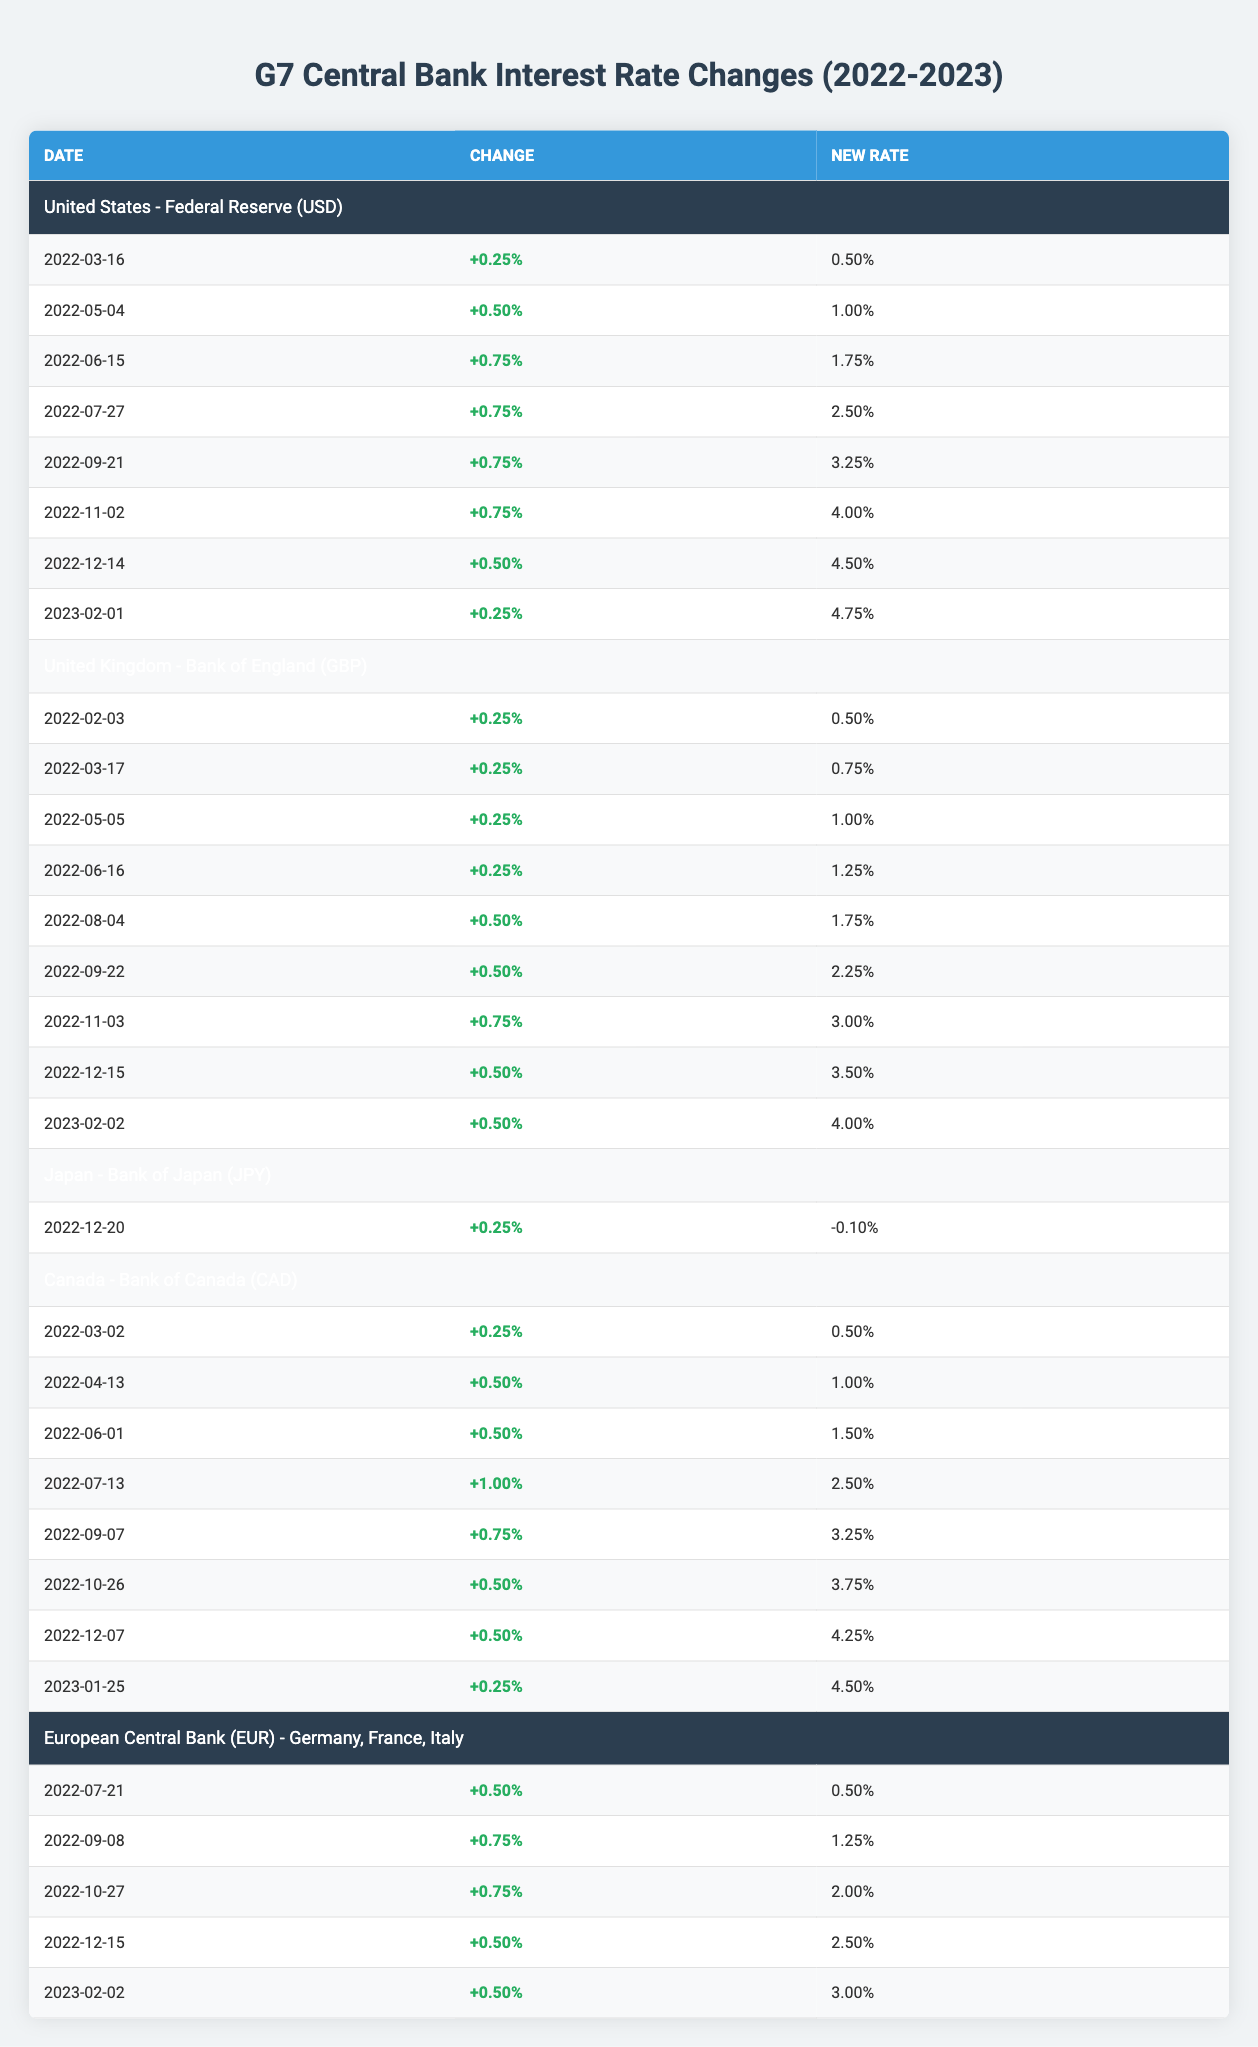What's the highest interest rate after changes by the Federal Reserve? The highest interest rate after changes by the Federal Reserve is 4.75%, which is listed in the row for the date 2023-02-01.
Answer: 4.75% Which bank raised rates by 1.00% in a single change? The Bank of Canada raised rates by 1.00% on 2022-07-13, which is shown in the corresponding row.
Answer: Bank of Canada Did Japan's Bank of Japan make multiple interest rate changes in the year? No, the Bank of Japan only changed the interest rate once on 2022-12-20, therefore it did not make multiple changes.
Answer: No What was the average interest rate change by the European Central Bank from July 2022 to February 2023? The interest rate changes during this period were +0.50%, +0.75%, +0.75%, +0.50%, and +0.50%. Summing these gives 2.50%, and dividing by 5 gives an average of 0.50%.
Answer: 0.50% Which country's central bank had the most frequent interest rate changes in the past year? The Federal Reserve of the United States had 8 changes listed, which is more than any other bank in the table.
Answer: United States 